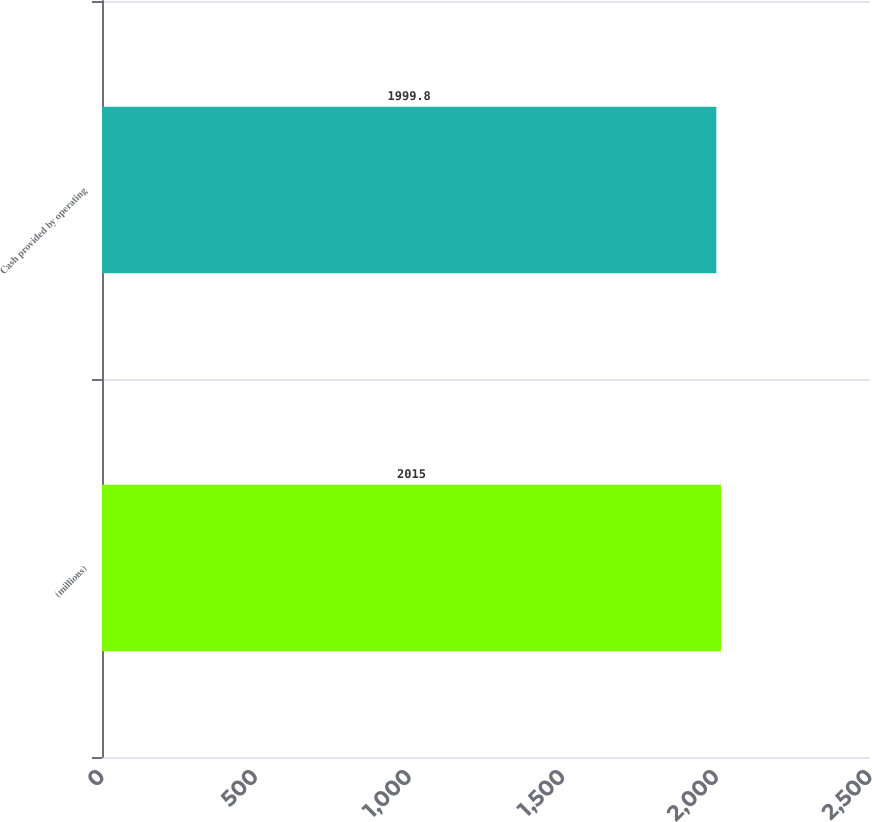<chart> <loc_0><loc_0><loc_500><loc_500><bar_chart><fcel>(millions)<fcel>Cash provided by operating<nl><fcel>2015<fcel>1999.8<nl></chart> 